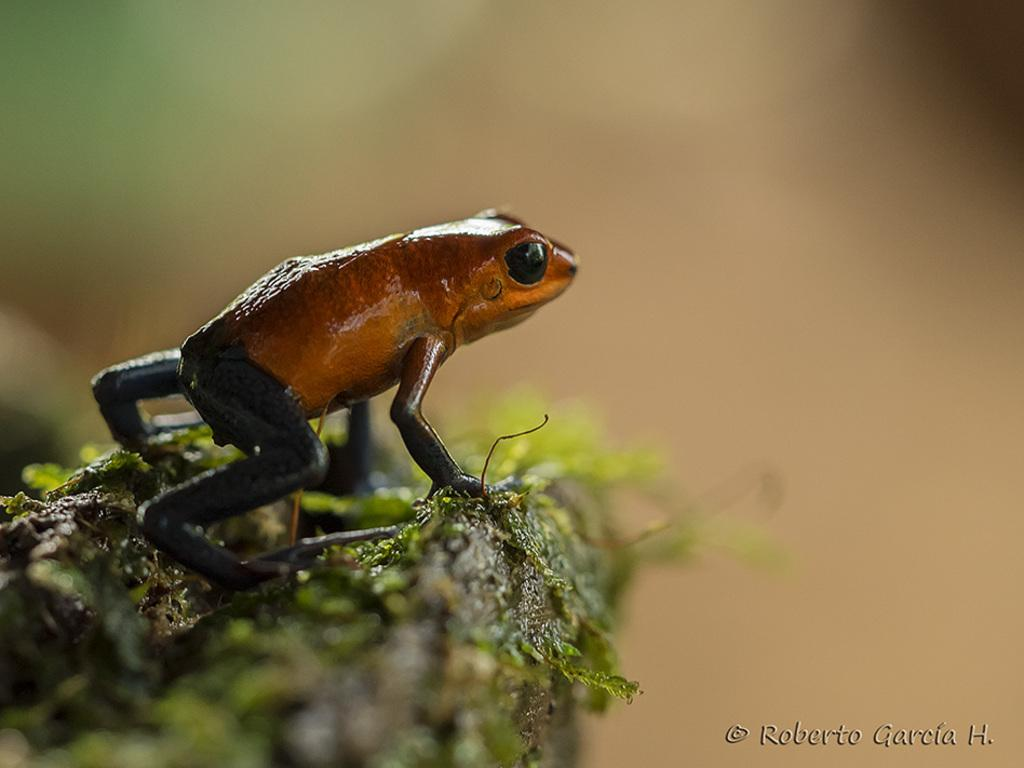What animal can be seen on the path in the image? There is a frog on the path in the image. Can you describe the background of the image? The background is blurred in the image. Is there any additional information or branding on the image? Yes, there is a watermark on the image. How many apples are hanging from the tree in the image? There is no tree or apples present in the image; it features a frog on a path with a blurred background and a watermark. 